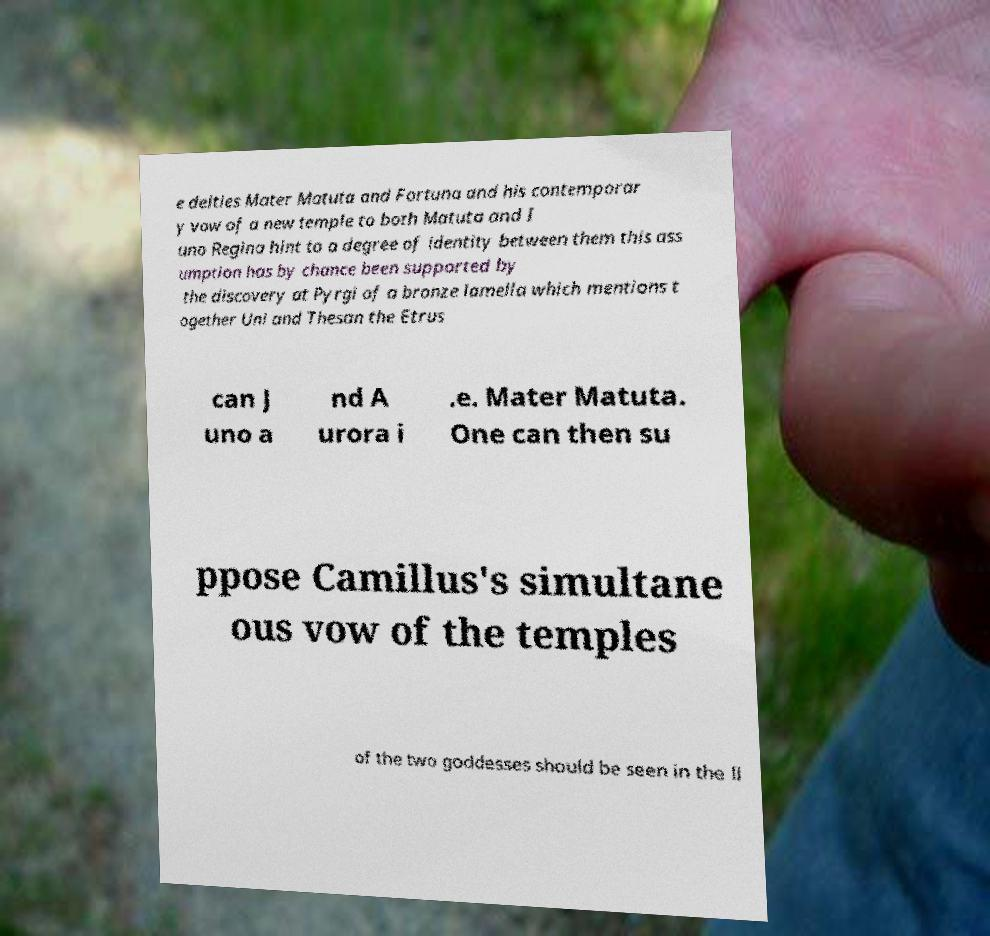What messages or text are displayed in this image? I need them in a readable, typed format. e deities Mater Matuta and Fortuna and his contemporar y vow of a new temple to both Matuta and I uno Regina hint to a degree of identity between them this ass umption has by chance been supported by the discovery at Pyrgi of a bronze lamella which mentions t ogether Uni and Thesan the Etrus can J uno a nd A urora i .e. Mater Matuta. One can then su ppose Camillus's simultane ous vow of the temples of the two goddesses should be seen in the li 